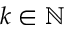Convert formula to latex. <formula><loc_0><loc_0><loc_500><loc_500>k \in \mathbb { N }</formula> 